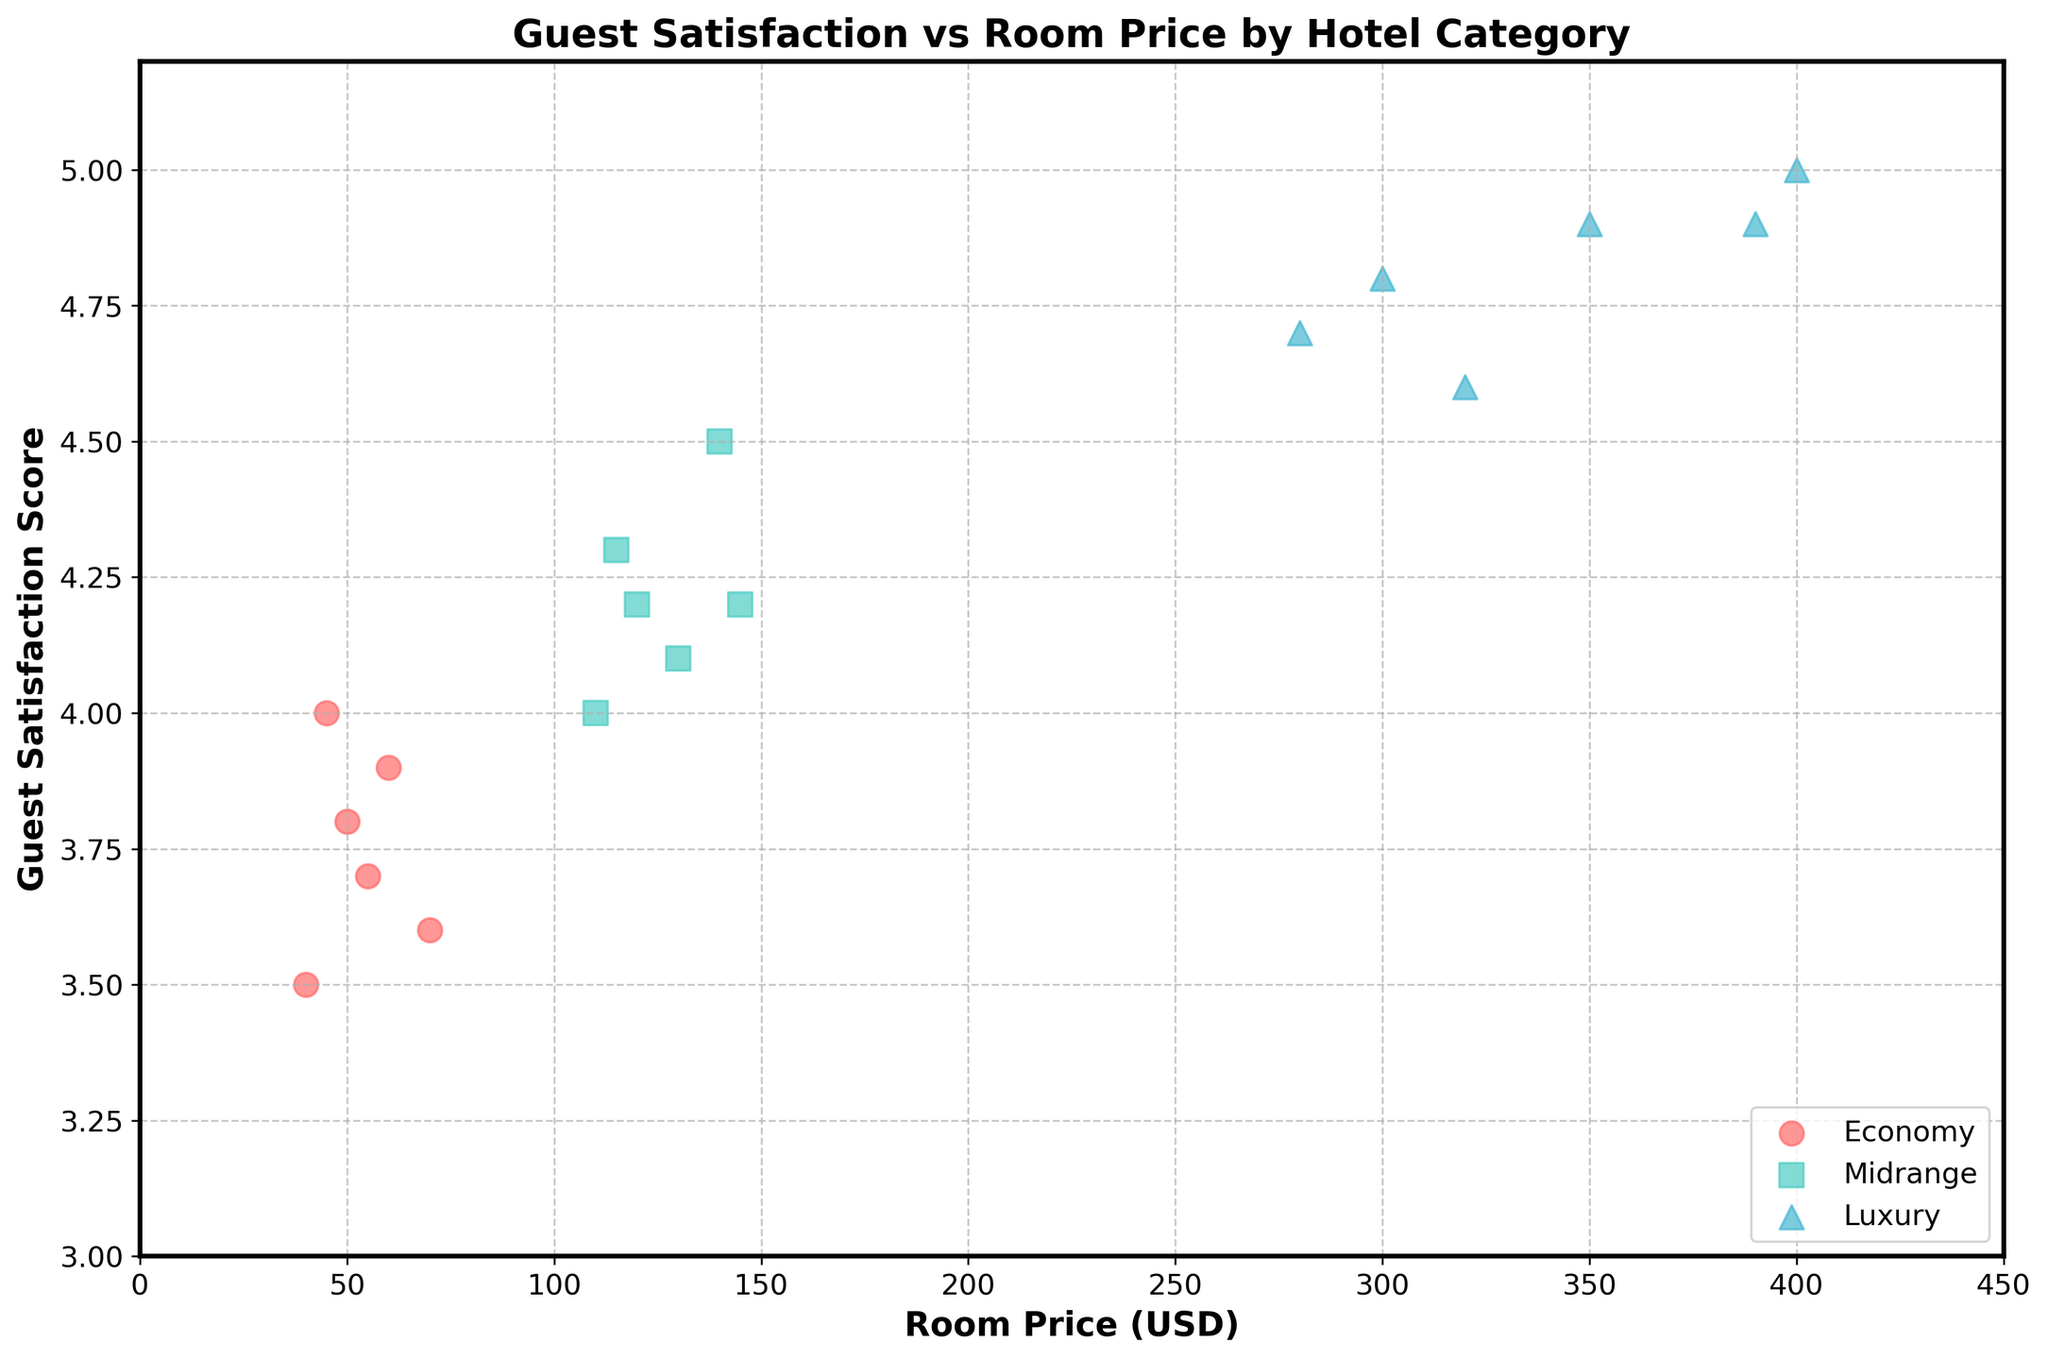What is the title of the plot? The plot's title can be found at the top of the figure.
Answer: Guest Satisfaction vs Room Price by Hotel Category What is the highest guest satisfaction score among the Luxury hotels? Identify the data points categorized as Luxury and locate the highest value on the y-axis for guest satisfaction score.
Answer: 5.0 Which hotel category has the lowest room price? Look at the x-axis and identify the category with data points at the lowest price end.
Answer: Economy How many data points represent the Midrange category? Count all the scatter points in the plot that are grouped under the Midrange label.
Answer: 6 What is the general trend of guest satisfaction scores as room prices increase for Luxury hotels? Observe the direction and pattern of the scatter points within the Luxury category.
Answer: Generally increases Compare the average room prices between Economy and Midrange categories. Which one is higher? Sum the room prices in each category, divide by the number of points, and compare the averages.
Answer: Midrange Which hotel has the highest room price? Look for the data point furthest to the right on the x-axis for room price and identify the corresponding hotel.
Answer: Five Star Deluxe Do higher room prices in the Midrange category generally indicate higher guest satisfaction scores? Inspect the pattern of scatter points within the Midrange category for a trend between increasing room prices and guest satisfaction scores.
Answer: Yes How do the guest satisfaction scores of Economy hotels compare to those of Luxury hotels? Observe and compare the range and pattern of scores in the Economy and Luxury categories on the y-axis.
Answer: Lower in general Based on the plot, are there more high-priced or low-priced hotels overall? Compare the density of scatter points on the left (low price) versus the right (high price) side of the x-axis.
Answer: More low-priced hotels 